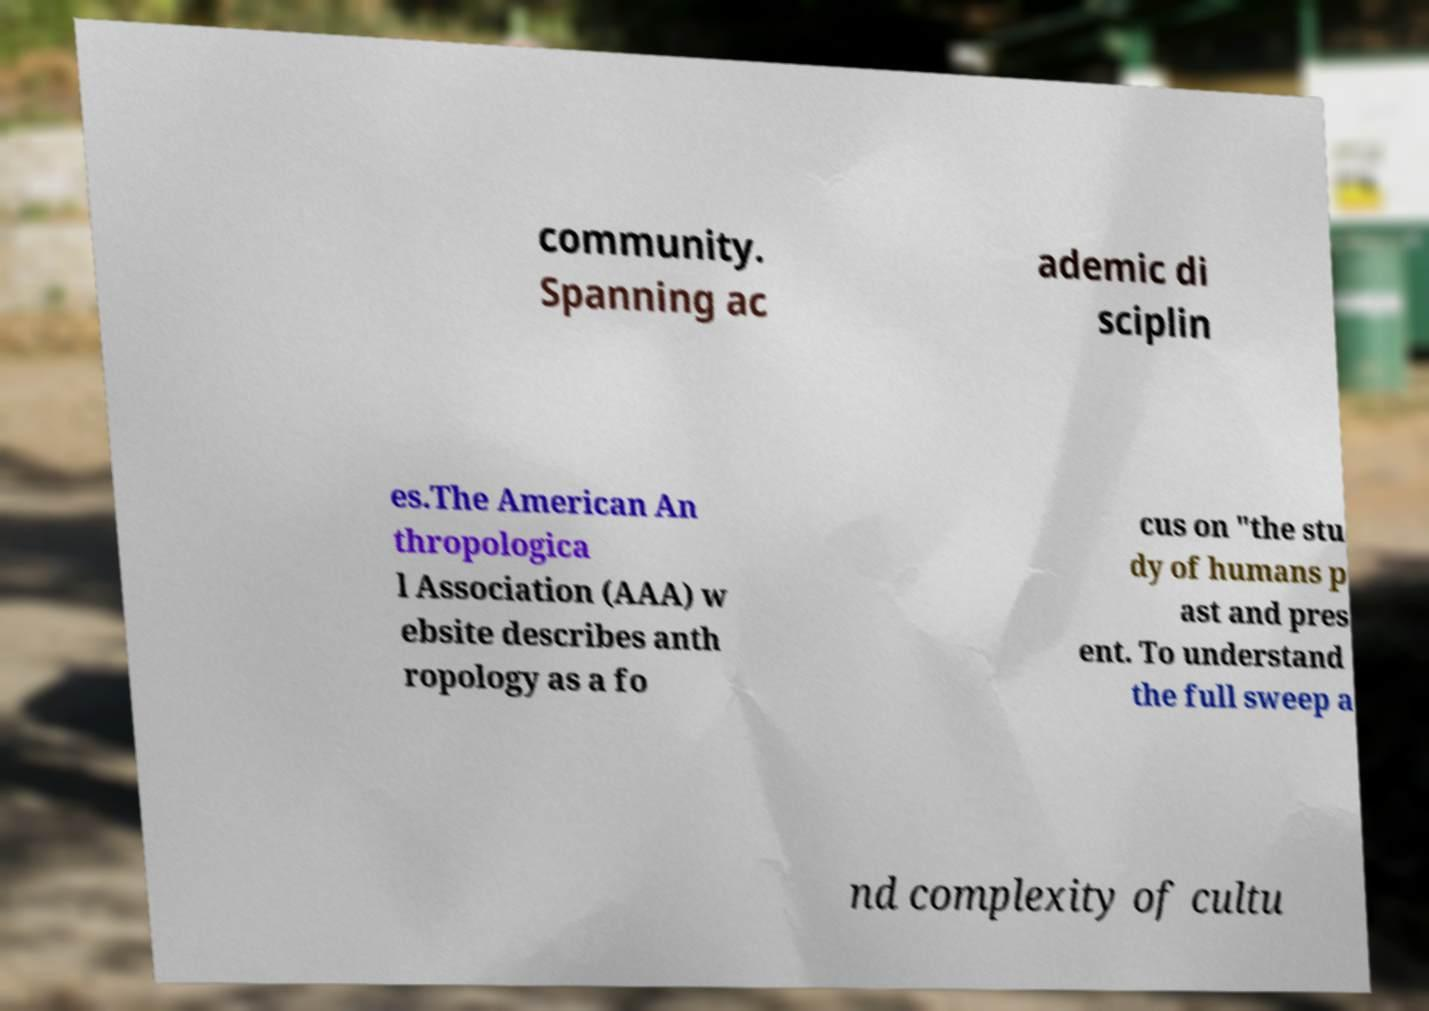There's text embedded in this image that I need extracted. Can you transcribe it verbatim? community. Spanning ac ademic di sciplin es.The American An thropologica l Association (AAA) w ebsite describes anth ropology as a fo cus on "the stu dy of humans p ast and pres ent. To understand the full sweep a nd complexity of cultu 